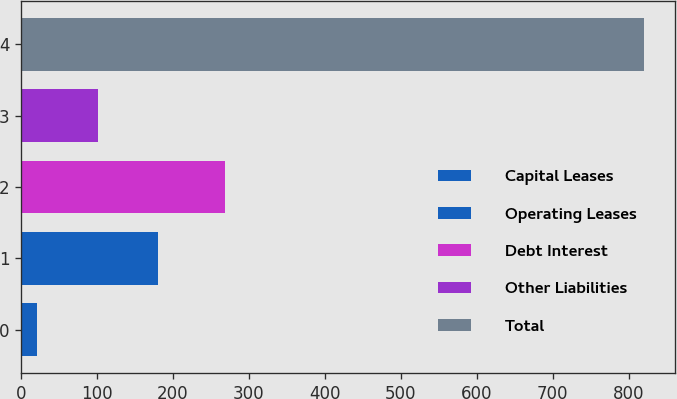Convert chart to OTSL. <chart><loc_0><loc_0><loc_500><loc_500><bar_chart><fcel>Capital Leases<fcel>Operating Leases<fcel>Debt Interest<fcel>Other Liabilities<fcel>Total<nl><fcel>21<fcel>180.8<fcel>269<fcel>100.9<fcel>820<nl></chart> 